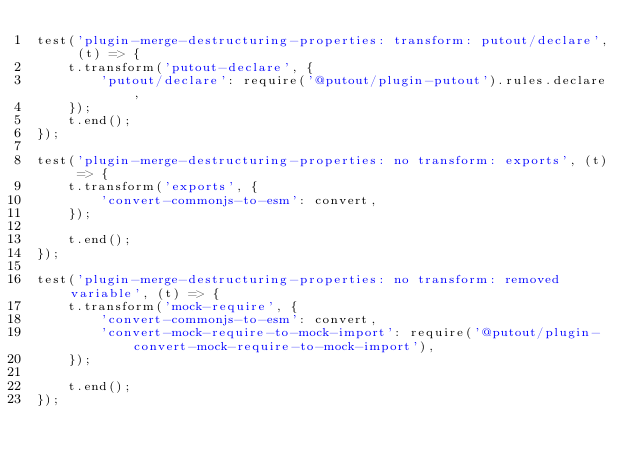Convert code to text. <code><loc_0><loc_0><loc_500><loc_500><_JavaScript_>test('plugin-merge-destructuring-properties: transform: putout/declare', (t) => {
    t.transform('putout-declare', {
        'putout/declare': require('@putout/plugin-putout').rules.declare,
    });
    t.end();
});

test('plugin-merge-destructuring-properties: no transform: exports', (t) => {
    t.transform('exports', {
        'convert-commonjs-to-esm': convert,
    });
    
    t.end();
});

test('plugin-merge-destructuring-properties: no transform: removed variable', (t) => {
    t.transform('mock-require', {
        'convert-commonjs-to-esm': convert,
        'convert-mock-require-to-mock-import': require('@putout/plugin-convert-mock-require-to-mock-import'),
    });
    
    t.end();
});

</code> 